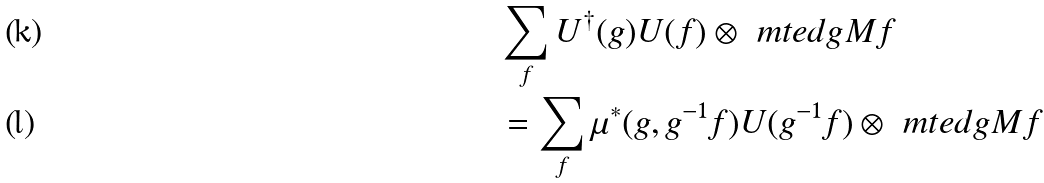<formula> <loc_0><loc_0><loc_500><loc_500>& \sum _ { f } U ^ { \dag } ( g ) U ( f ) \otimes \ m t e d { g } { M } { f } & \\ & = \sum _ { f } \mu ^ { \ast } ( g , g ^ { - 1 } f ) U ( g ^ { - 1 } f ) \otimes \ m t e d { g } { M } { f } &</formula> 